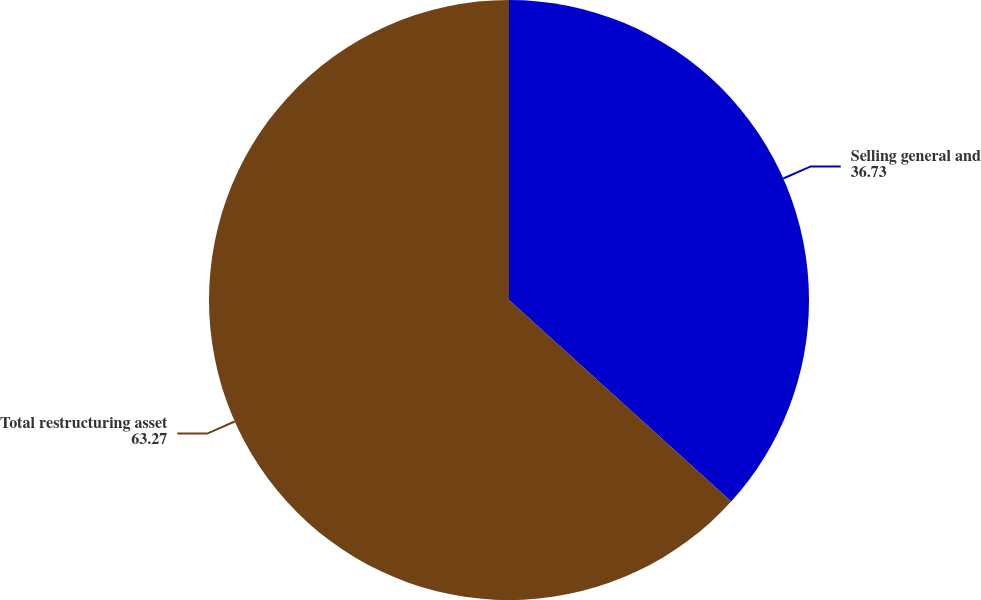<chart> <loc_0><loc_0><loc_500><loc_500><pie_chart><fcel>Selling general and<fcel>Total restructuring asset<nl><fcel>36.73%<fcel>63.27%<nl></chart> 